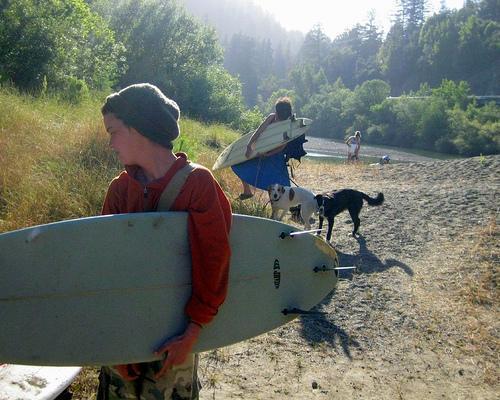How many dogs are there?
Give a very brief answer. 2. How many people are there?
Give a very brief answer. 2. 